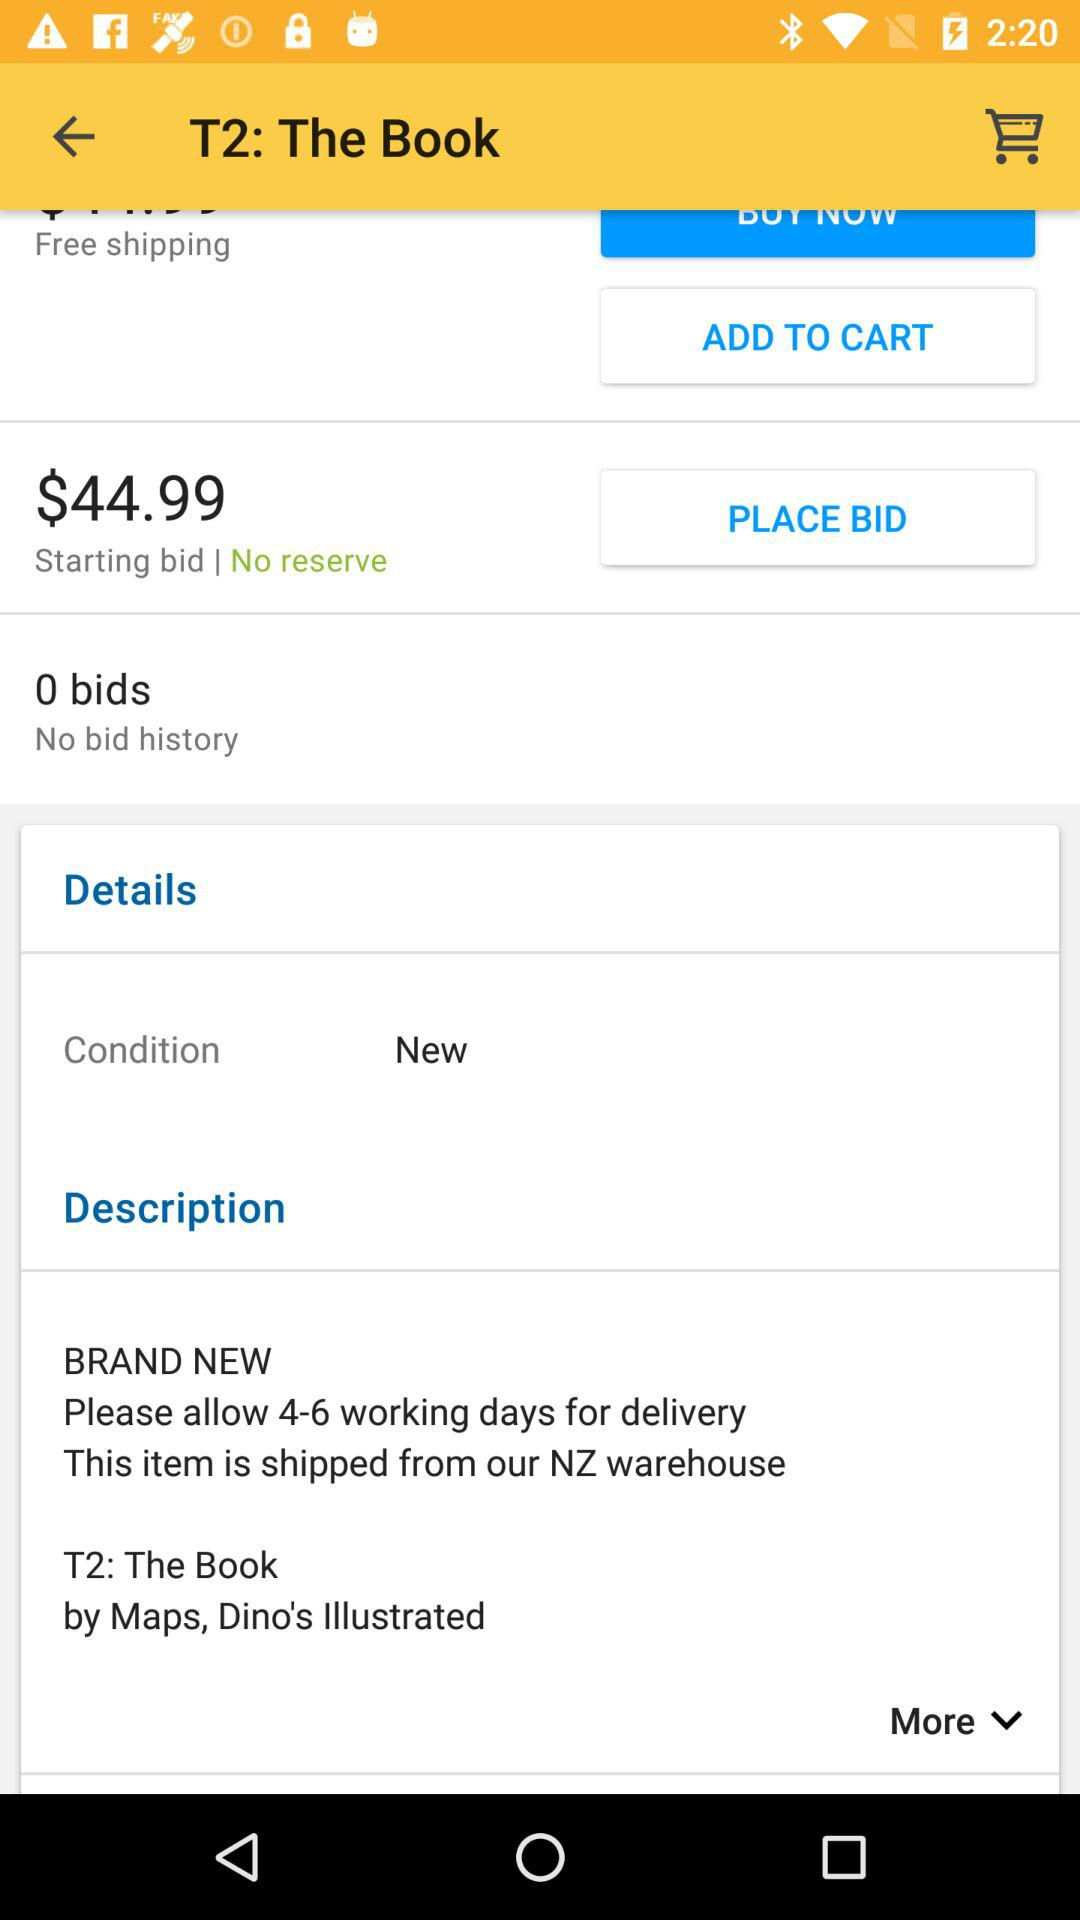What is the price of the item?
Answer the question using a single word or phrase. $44.99 